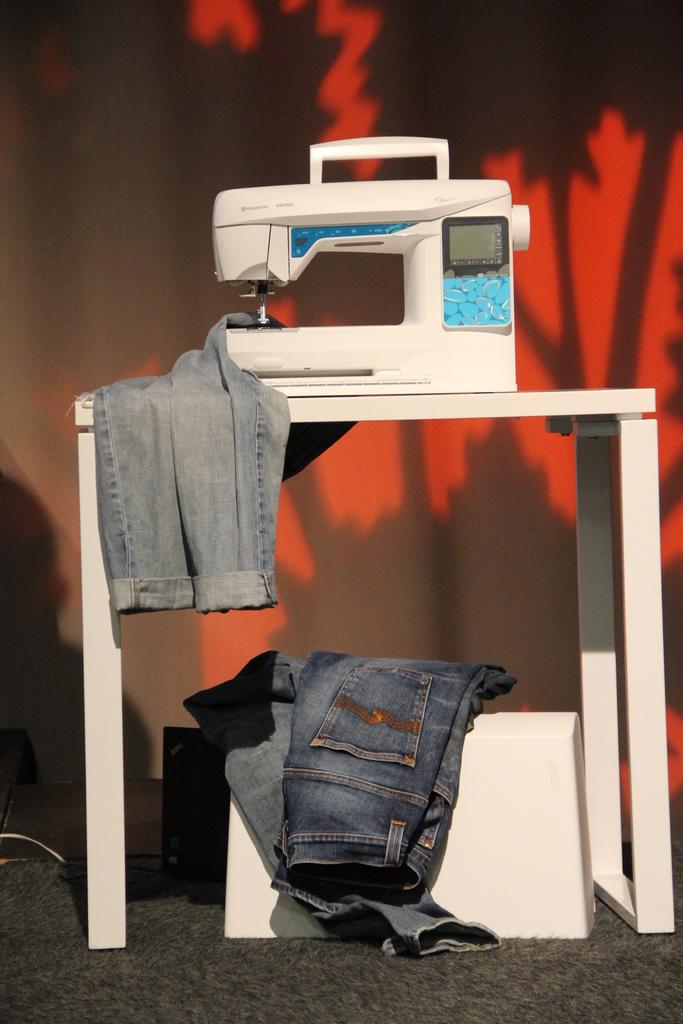What is the main object on the table in the image? There is a stitching machine on a table in the image. What else is on the table besides the stitching machine? There is a pair of jeans on the table. Can you describe the position of the second pair of jeans in the image? There is a pair of jeans on a white surface below the table. What can be seen in the background of the image? There is a wall in the background of the image. What type of marble is visible on the stitching machine in the image? There is no marble visible on the stitching machine in the image. How many stars can be seen in the image? There are no stars visible in the image. 